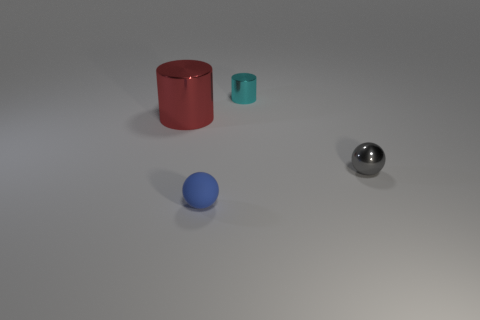Subtract 2 cylinders. How many cylinders are left? 0 Subtract all metal balls. Subtract all blue things. How many objects are left? 2 Add 4 cyan metal things. How many cyan metal things are left? 5 Add 4 red cubes. How many red cubes exist? 4 Add 2 metallic objects. How many objects exist? 6 Subtract all gray spheres. How many spheres are left? 1 Subtract 1 blue spheres. How many objects are left? 3 Subtract all red spheres. Subtract all red cubes. How many spheres are left? 2 Subtract all green balls. How many cyan cylinders are left? 1 